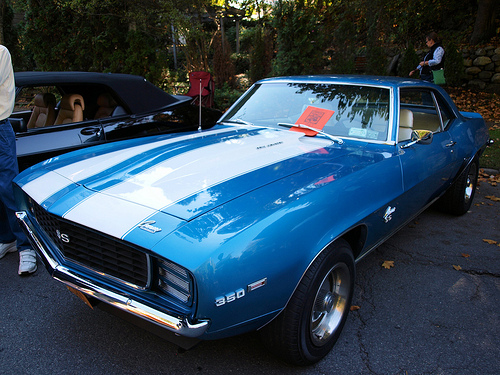<image>
Is there a car behind the man? No. The car is not behind the man. From this viewpoint, the car appears to be positioned elsewhere in the scene. 